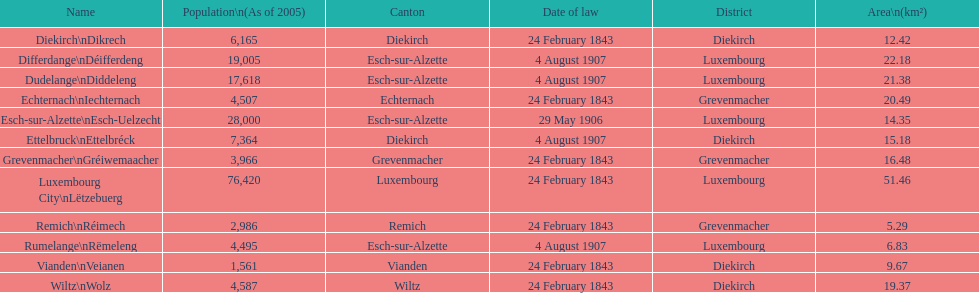How many diekirch districts also have diekirch as their canton? 2. 